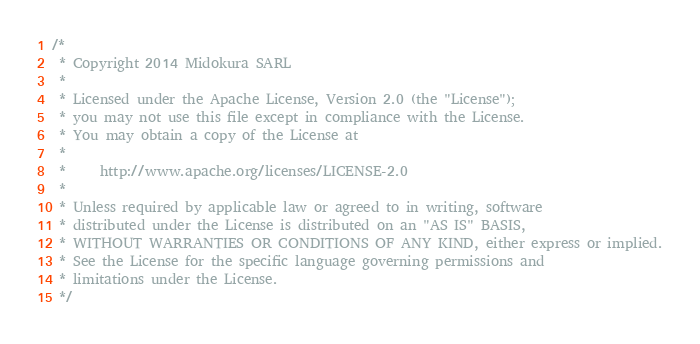<code> <loc_0><loc_0><loc_500><loc_500><_Scala_>/*
 * Copyright 2014 Midokura SARL
 *
 * Licensed under the Apache License, Version 2.0 (the "License");
 * you may not use this file except in compliance with the License.
 * You may obtain a copy of the License at
 *
 *     http://www.apache.org/licenses/LICENSE-2.0
 *
 * Unless required by applicable law or agreed to in writing, software
 * distributed under the License is distributed on an "AS IS" BASIS,
 * WITHOUT WARRANTIES OR CONDITIONS OF ANY KIND, either express or implied.
 * See the License for the specific language governing permissions and
 * limitations under the License.
 */</code> 